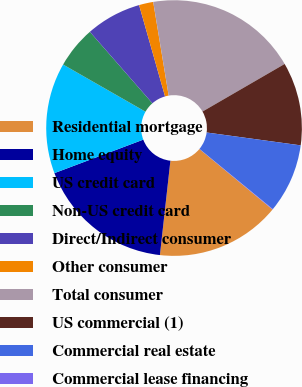Convert chart. <chart><loc_0><loc_0><loc_500><loc_500><pie_chart><fcel>Residential mortgage<fcel>Home equity<fcel>US credit card<fcel>Non-US credit card<fcel>Direct/Indirect consumer<fcel>Other consumer<fcel>Total consumer<fcel>US commercial (1)<fcel>Commercial real estate<fcel>Commercial lease financing<nl><fcel>15.76%<fcel>17.5%<fcel>14.01%<fcel>5.29%<fcel>7.03%<fcel>1.8%<fcel>19.25%<fcel>10.52%<fcel>8.78%<fcel>0.06%<nl></chart> 